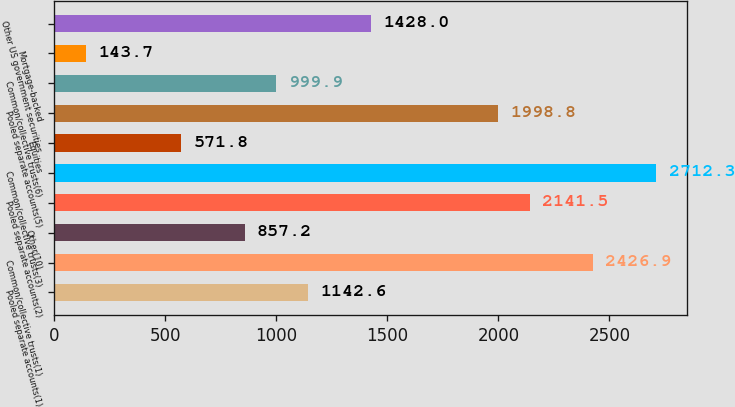<chart> <loc_0><loc_0><loc_500><loc_500><bar_chart><fcel>Pooled separate accounts(1)<fcel>Common/collective trusts(1)<fcel>Other(10)<fcel>Pooled separate accounts(2)<fcel>Common/collective trusts(3)<fcel>Equities<fcel>Pooled separate accounts(5)<fcel>Common/collective trusts(6)<fcel>Mortgage-backed<fcel>Other US government securities<nl><fcel>1142.6<fcel>2426.9<fcel>857.2<fcel>2141.5<fcel>2712.3<fcel>571.8<fcel>1998.8<fcel>999.9<fcel>143.7<fcel>1428<nl></chart> 